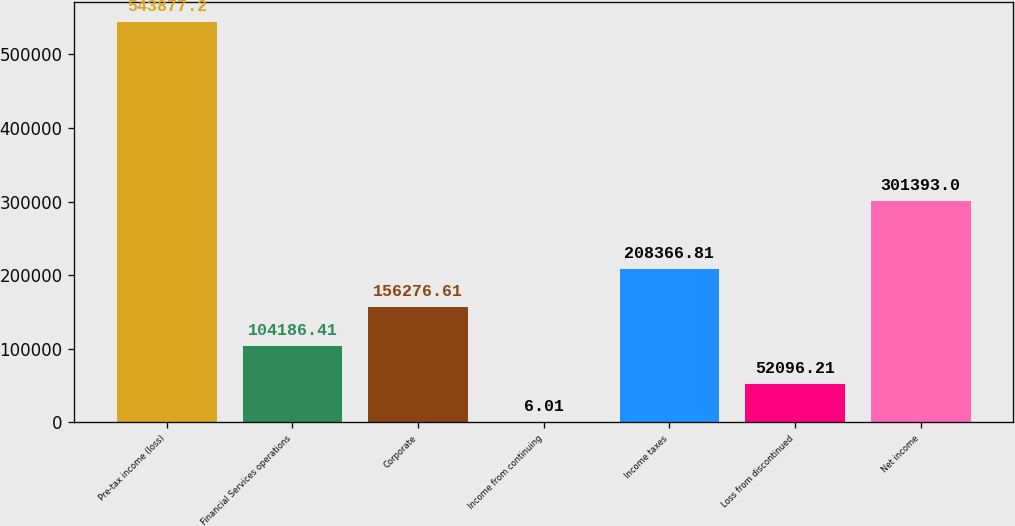Convert chart. <chart><loc_0><loc_0><loc_500><loc_500><bar_chart><fcel>Pre-tax income (loss)<fcel>Financial Services operations<fcel>Corporate<fcel>Income from continuing<fcel>Income taxes<fcel>Loss from discontinued<fcel>Net income<nl><fcel>543877<fcel>104186<fcel>156277<fcel>6.01<fcel>208367<fcel>52096.2<fcel>301393<nl></chart> 